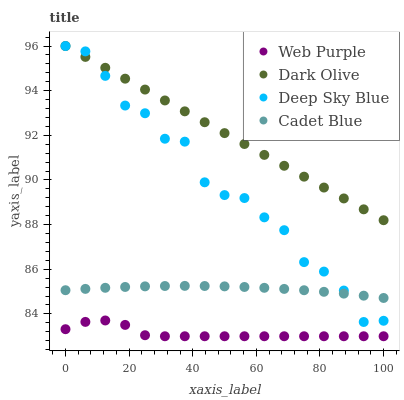Does Web Purple have the minimum area under the curve?
Answer yes or no. Yes. Does Dark Olive have the maximum area under the curve?
Answer yes or no. Yes. Does Dark Olive have the minimum area under the curve?
Answer yes or no. No. Does Web Purple have the maximum area under the curve?
Answer yes or no. No. Is Dark Olive the smoothest?
Answer yes or no. Yes. Is Deep Sky Blue the roughest?
Answer yes or no. Yes. Is Web Purple the smoothest?
Answer yes or no. No. Is Web Purple the roughest?
Answer yes or no. No. Does Web Purple have the lowest value?
Answer yes or no. Yes. Does Dark Olive have the lowest value?
Answer yes or no. No. Does Deep Sky Blue have the highest value?
Answer yes or no. Yes. Does Web Purple have the highest value?
Answer yes or no. No. Is Web Purple less than Dark Olive?
Answer yes or no. Yes. Is Cadet Blue greater than Web Purple?
Answer yes or no. Yes. Does Deep Sky Blue intersect Dark Olive?
Answer yes or no. Yes. Is Deep Sky Blue less than Dark Olive?
Answer yes or no. No. Is Deep Sky Blue greater than Dark Olive?
Answer yes or no. No. Does Web Purple intersect Dark Olive?
Answer yes or no. No. 